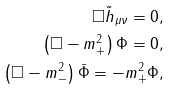<formula> <loc_0><loc_0><loc_500><loc_500>\square \tilde { h } _ { \mu \nu } = 0 , \\ \left ( \square - m _ { + } ^ { 2 } \right ) \Phi = 0 , \\ \left ( \square - m _ { - } ^ { 2 } \right ) \bar { \Phi } = - m _ { + } ^ { 2 } \Phi ,</formula> 